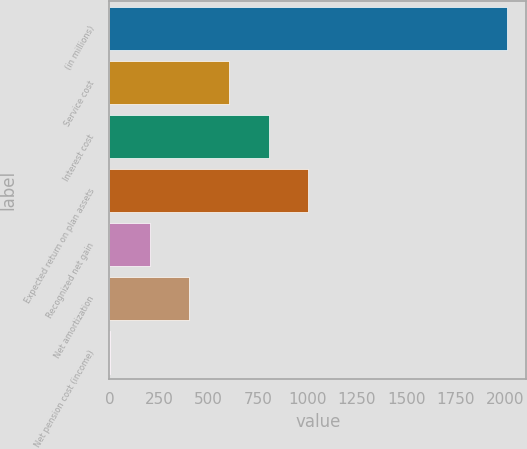<chart> <loc_0><loc_0><loc_500><loc_500><bar_chart><fcel>(in millions)<fcel>Service cost<fcel>Interest cost<fcel>Expected return on plan assets<fcel>Recognized net gain<fcel>Net amortization<fcel>Net pension cost (income)<nl><fcel>2005<fcel>602.9<fcel>803.2<fcel>1003.5<fcel>202.3<fcel>402.6<fcel>2<nl></chart> 